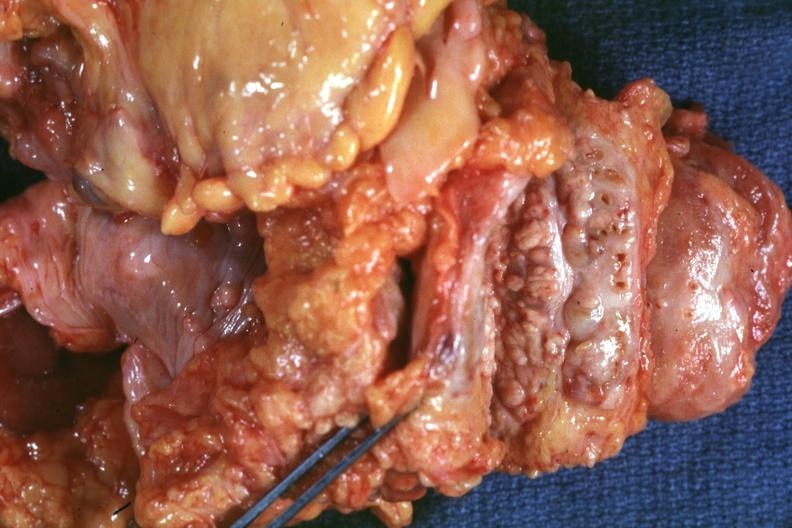what is present?
Answer the question using a single word or phrase. Adenocarcinoma 